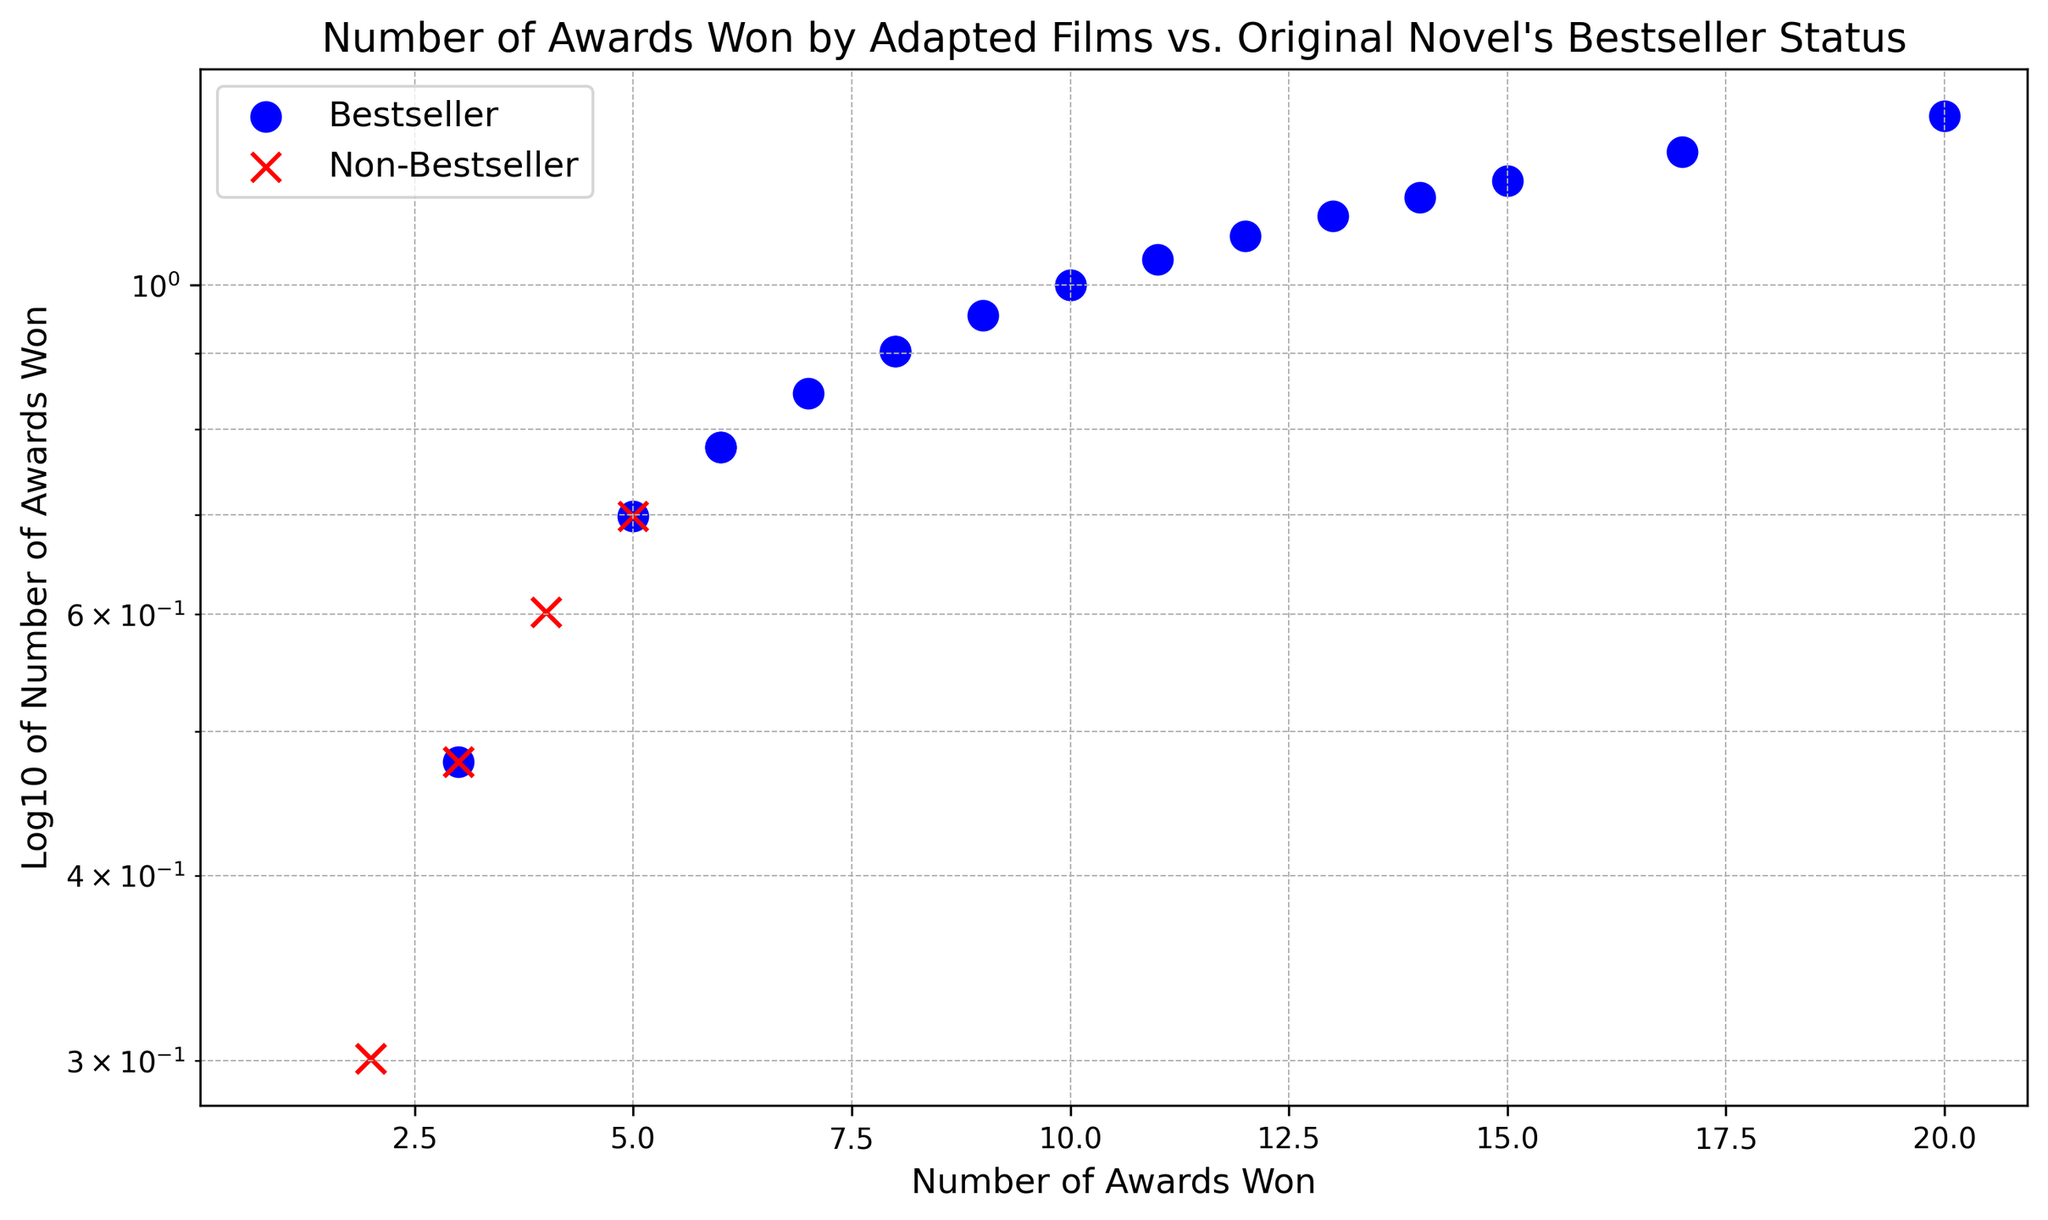what is the total number of 'Bestseller' films that won at least 10 awards? To find the total, look at the 'Bestseller' category in the plot and count the points that correspond to films winning 10 or more awards.
Answer: 7 How does the log-transformed number of awards compare between the highest-scoring 'Bestseller' and 'Non-Bestseller'? Identify the highest number of awards in each category and compare their log-transformed values. The highest 'Bestseller' has 20 awards (Log10(20)) and the highest 'Non-Bestseller' has 4 awards (Log10(4)).
Answer: Log10(20) > Log10(4) How many more 'Non-Bestseller' films won between 1 and 3 awards compared to 'Bestseller' films? Count the points within the 1 to 3 awards range for both categories and then subtract the two counts. 'Non-Bestseller' = 4 (1, 1, 2, 3) and 'Bestseller' = 2 (3, 3).
Answer: 2 more What is the range of the awards won by 'Bestseller' films? Determine the minimum and maximum number of awards won by 'Bestseller' films. Minimum is 3, and Maximum is 20.
Answer: 3 to 20 What's the average number of awards won by 'Non-Bestseller' films? Sum up the awards won by 'Non-Bestseller' films and divide by their count. Awards: (1, 3, 2, 4, 1, 3, 2, 2, 4, 5, 3, 1). Sum = 33, count = 12, so the average = 33/12.
Answer: 2.75 